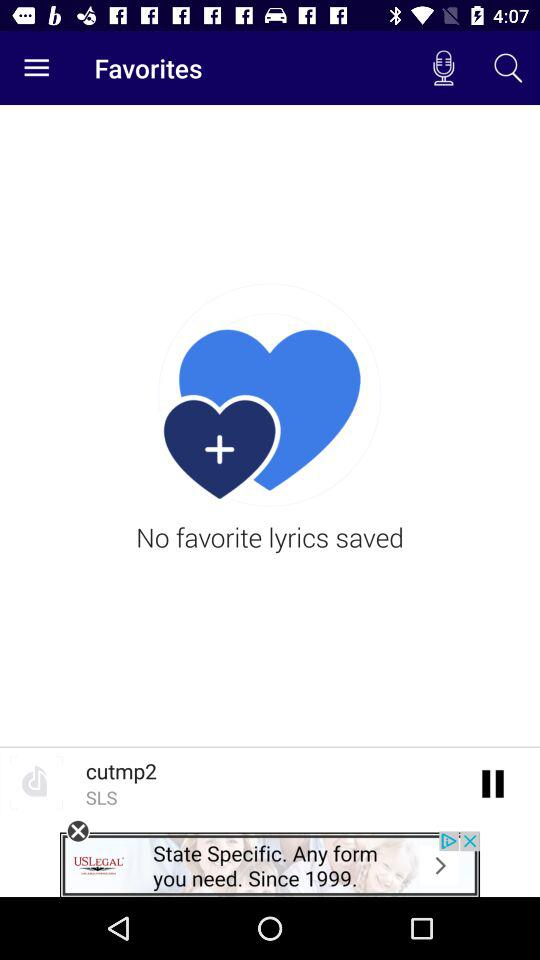Which song is currently playing? The currently playing song is "cutmp2". 